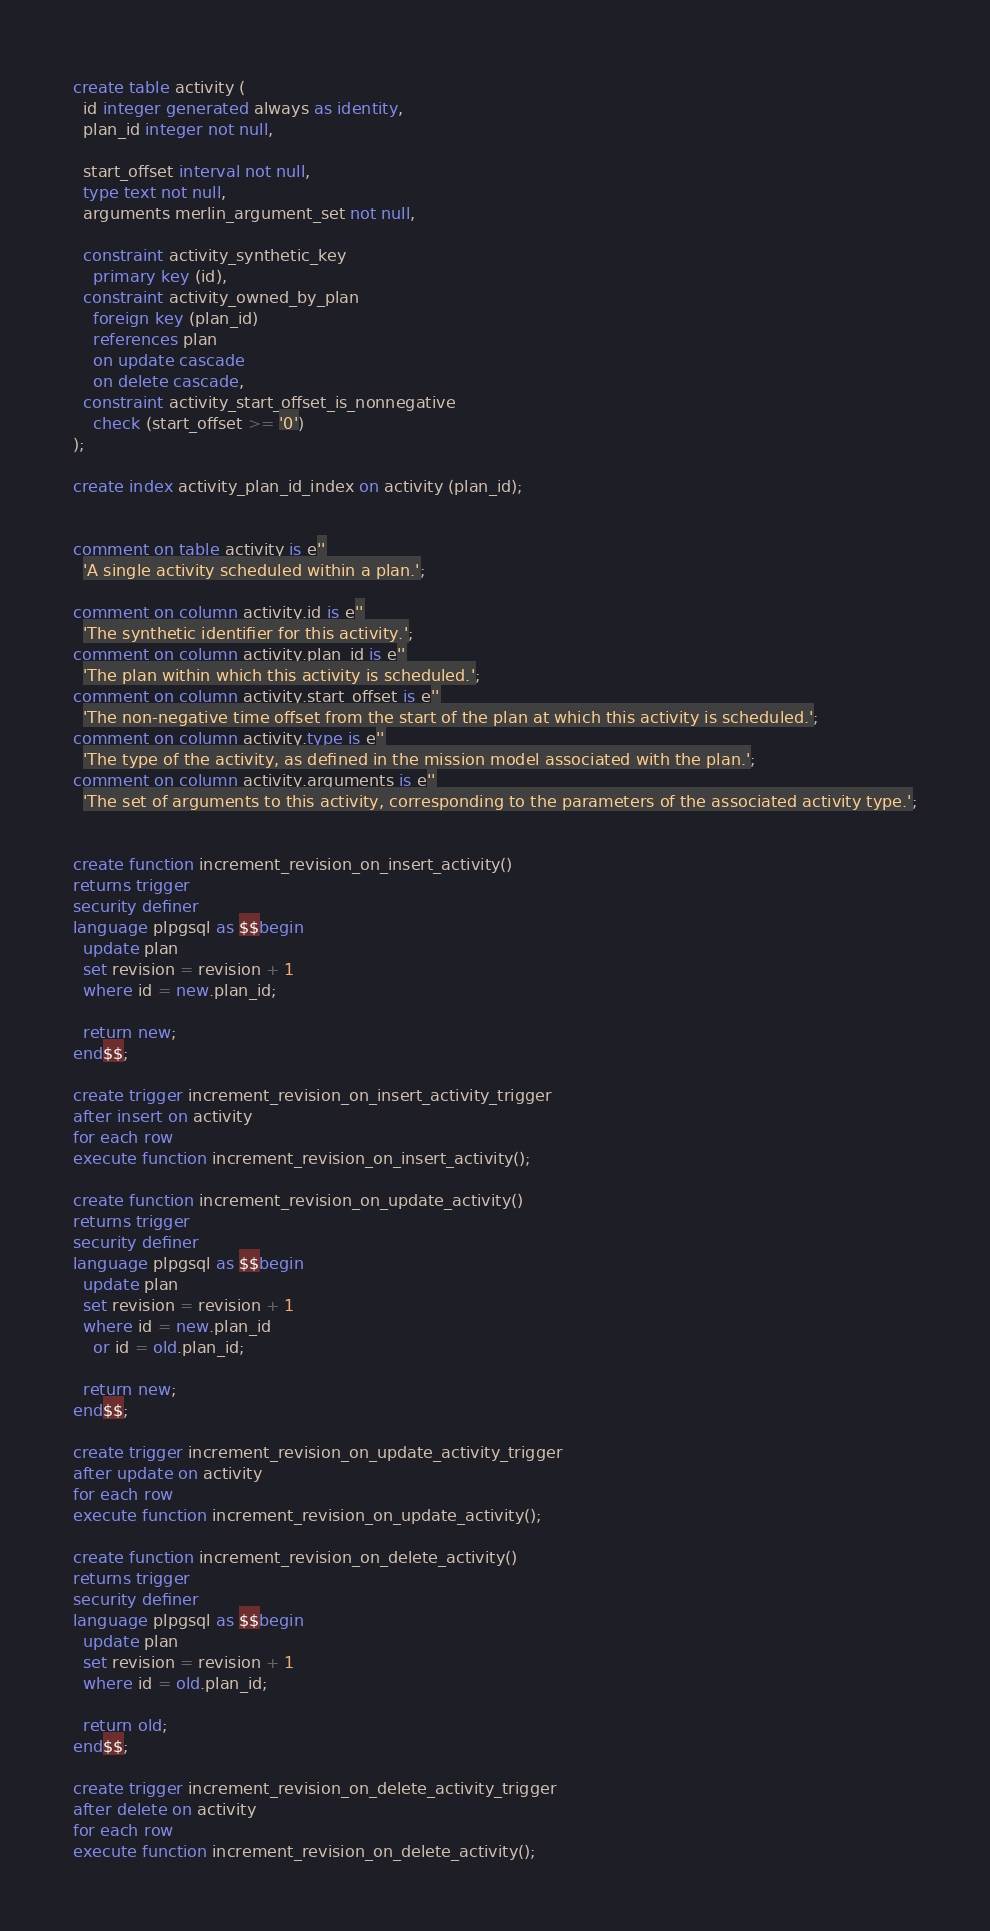<code> <loc_0><loc_0><loc_500><loc_500><_SQL_>create table activity (
  id integer generated always as identity,
  plan_id integer not null,

  start_offset interval not null,
  type text not null,
  arguments merlin_argument_set not null,

  constraint activity_synthetic_key
    primary key (id),
  constraint activity_owned_by_plan
    foreign key (plan_id)
    references plan
    on update cascade
    on delete cascade,
  constraint activity_start_offset_is_nonnegative
    check (start_offset >= '0')
);

create index activity_plan_id_index on activity (plan_id);


comment on table activity is e''
  'A single activity scheduled within a plan.';

comment on column activity.id is e''
  'The synthetic identifier for this activity.';
comment on column activity.plan_id is e''
  'The plan within which this activity is scheduled.';
comment on column activity.start_offset is e''
  'The non-negative time offset from the start of the plan at which this activity is scheduled.';
comment on column activity.type is e''
  'The type of the activity, as defined in the mission model associated with the plan.';
comment on column activity.arguments is e''
  'The set of arguments to this activity, corresponding to the parameters of the associated activity type.';


create function increment_revision_on_insert_activity()
returns trigger
security definer
language plpgsql as $$begin
  update plan
  set revision = revision + 1
  where id = new.plan_id;

  return new;
end$$;

create trigger increment_revision_on_insert_activity_trigger
after insert on activity
for each row
execute function increment_revision_on_insert_activity();

create function increment_revision_on_update_activity()
returns trigger
security definer
language plpgsql as $$begin
  update plan
  set revision = revision + 1
  where id = new.plan_id
    or id = old.plan_id;

  return new;
end$$;

create trigger increment_revision_on_update_activity_trigger
after update on activity
for each row
execute function increment_revision_on_update_activity();

create function increment_revision_on_delete_activity()
returns trigger
security definer
language plpgsql as $$begin
  update plan
  set revision = revision + 1
  where id = old.plan_id;

  return old;
end$$;

create trigger increment_revision_on_delete_activity_trigger
after delete on activity
for each row
execute function increment_revision_on_delete_activity();
</code> 